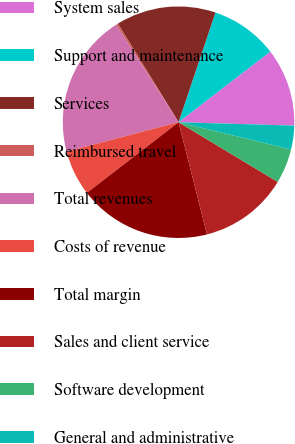Convert chart. <chart><loc_0><loc_0><loc_500><loc_500><pie_chart><fcel>System sales<fcel>Support and maintenance<fcel>Services<fcel>Reimbursed travel<fcel>Total revenues<fcel>Costs of revenue<fcel>Total margin<fcel>Sales and client service<fcel>Software development<fcel>General and administrative<nl><fcel>10.91%<fcel>9.39%<fcel>13.95%<fcel>0.29%<fcel>20.02%<fcel>6.36%<fcel>18.5%<fcel>12.43%<fcel>4.84%<fcel>3.32%<nl></chart> 